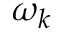Convert formula to latex. <formula><loc_0><loc_0><loc_500><loc_500>\omega _ { k }</formula> 